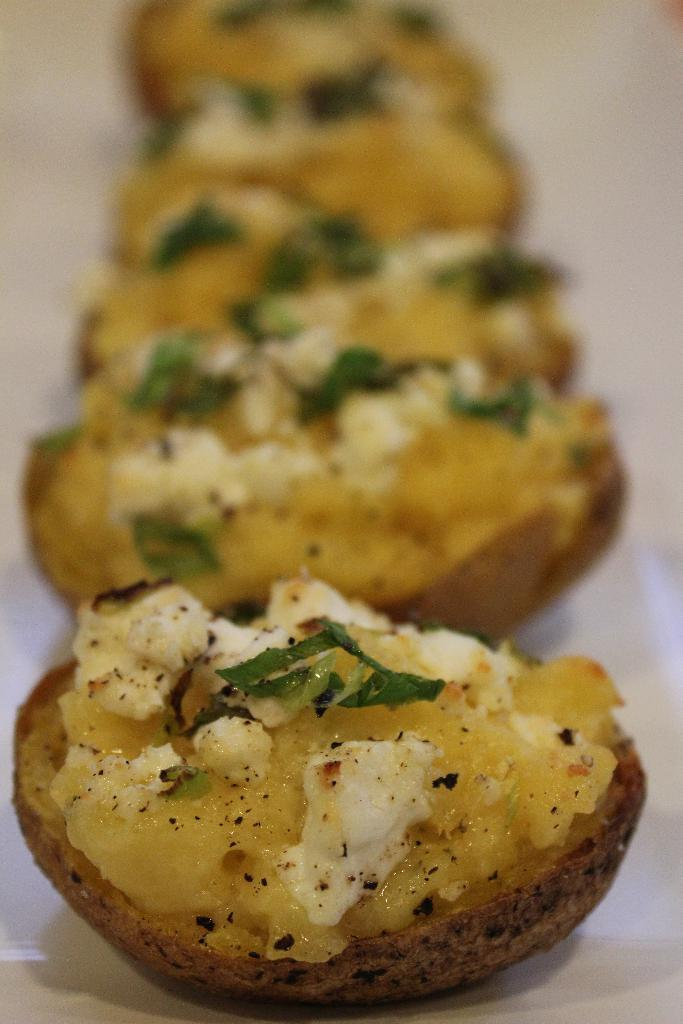What is present on the surface in the image? There is food on a surface in the image. What type of surface is the food placed on? The surface resembles a table. Can you describe the top part of the image? The top of the image is blurred. What type of thread is being used in the crime scene depicted in the image? There is no crime scene or thread present in the image; it features food on a table with a blurred top part. 